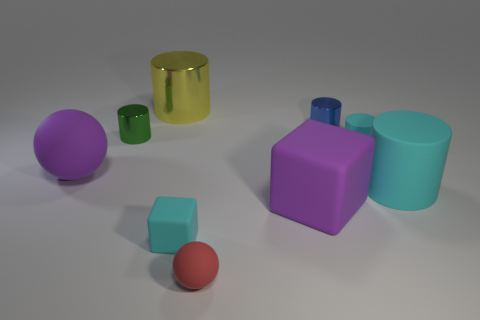Do the small block and the small rubber cylinder have the same color?
Keep it short and to the point. Yes. Are there more rubber balls than large rubber objects?
Provide a short and direct response. No. What number of blue matte objects are there?
Provide a succinct answer. 0. What shape is the big purple matte object that is on the right side of the big purple matte thing on the left side of the small shiny cylinder to the left of the small cyan matte block?
Provide a succinct answer. Cube. Are there fewer small green things that are in front of the cyan rubber block than large blocks that are in front of the small matte sphere?
Your response must be concise. No. There is a small cyan rubber thing on the right side of the small cyan matte cube; does it have the same shape as the purple thing that is behind the big rubber cylinder?
Your answer should be very brief. No. The small cyan rubber object that is left of the shiny cylinder to the right of the red thing is what shape?
Provide a short and direct response. Cube. There is a matte block that is the same color as the large rubber ball; what size is it?
Keep it short and to the point. Large. Is there a tiny red thing that has the same material as the red ball?
Provide a short and direct response. No. What is the big cylinder behind the big matte cylinder made of?
Your response must be concise. Metal. 